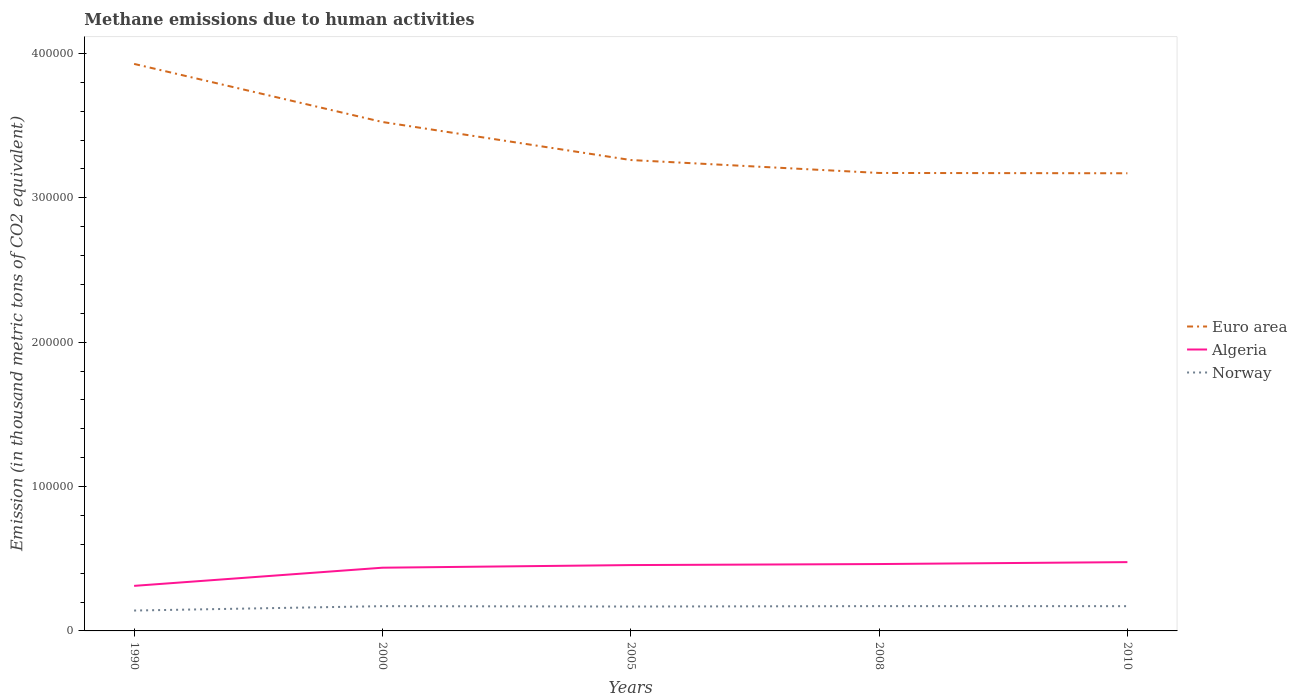Is the number of lines equal to the number of legend labels?
Your answer should be compact. Yes. Across all years, what is the maximum amount of methane emitted in Algeria?
Make the answer very short. 3.12e+04. What is the total amount of methane emitted in Norway in the graph?
Provide a short and direct response. 254.8. What is the difference between the highest and the second highest amount of methane emitted in Euro area?
Offer a very short reply. 7.58e+04. Are the values on the major ticks of Y-axis written in scientific E-notation?
Keep it short and to the point. No. Does the graph contain any zero values?
Offer a terse response. No. Does the graph contain grids?
Ensure brevity in your answer.  No. Where does the legend appear in the graph?
Your answer should be compact. Center right. How are the legend labels stacked?
Offer a very short reply. Vertical. What is the title of the graph?
Provide a short and direct response. Methane emissions due to human activities. Does "Iceland" appear as one of the legend labels in the graph?
Give a very brief answer. No. What is the label or title of the Y-axis?
Make the answer very short. Emission (in thousand metric tons of CO2 equivalent). What is the Emission (in thousand metric tons of CO2 equivalent) in Euro area in 1990?
Provide a succinct answer. 3.93e+05. What is the Emission (in thousand metric tons of CO2 equivalent) of Algeria in 1990?
Your response must be concise. 3.12e+04. What is the Emission (in thousand metric tons of CO2 equivalent) of Norway in 1990?
Make the answer very short. 1.41e+04. What is the Emission (in thousand metric tons of CO2 equivalent) of Euro area in 2000?
Keep it short and to the point. 3.53e+05. What is the Emission (in thousand metric tons of CO2 equivalent) of Algeria in 2000?
Your response must be concise. 4.38e+04. What is the Emission (in thousand metric tons of CO2 equivalent) of Norway in 2000?
Provide a succinct answer. 1.72e+04. What is the Emission (in thousand metric tons of CO2 equivalent) of Euro area in 2005?
Provide a short and direct response. 3.26e+05. What is the Emission (in thousand metric tons of CO2 equivalent) in Algeria in 2005?
Provide a short and direct response. 4.56e+04. What is the Emission (in thousand metric tons of CO2 equivalent) of Norway in 2005?
Offer a very short reply. 1.69e+04. What is the Emission (in thousand metric tons of CO2 equivalent) in Euro area in 2008?
Make the answer very short. 3.17e+05. What is the Emission (in thousand metric tons of CO2 equivalent) in Algeria in 2008?
Your response must be concise. 4.63e+04. What is the Emission (in thousand metric tons of CO2 equivalent) of Norway in 2008?
Your answer should be compact. 1.72e+04. What is the Emission (in thousand metric tons of CO2 equivalent) of Euro area in 2010?
Offer a terse response. 3.17e+05. What is the Emission (in thousand metric tons of CO2 equivalent) in Algeria in 2010?
Offer a terse response. 4.77e+04. What is the Emission (in thousand metric tons of CO2 equivalent) of Norway in 2010?
Your response must be concise. 1.71e+04. Across all years, what is the maximum Emission (in thousand metric tons of CO2 equivalent) of Euro area?
Offer a terse response. 3.93e+05. Across all years, what is the maximum Emission (in thousand metric tons of CO2 equivalent) in Algeria?
Make the answer very short. 4.77e+04. Across all years, what is the maximum Emission (in thousand metric tons of CO2 equivalent) of Norway?
Make the answer very short. 1.72e+04. Across all years, what is the minimum Emission (in thousand metric tons of CO2 equivalent) of Euro area?
Ensure brevity in your answer.  3.17e+05. Across all years, what is the minimum Emission (in thousand metric tons of CO2 equivalent) of Algeria?
Offer a very short reply. 3.12e+04. Across all years, what is the minimum Emission (in thousand metric tons of CO2 equivalent) in Norway?
Make the answer very short. 1.41e+04. What is the total Emission (in thousand metric tons of CO2 equivalent) of Euro area in the graph?
Make the answer very short. 1.71e+06. What is the total Emission (in thousand metric tons of CO2 equivalent) in Algeria in the graph?
Give a very brief answer. 2.15e+05. What is the total Emission (in thousand metric tons of CO2 equivalent) of Norway in the graph?
Your answer should be very brief. 8.25e+04. What is the difference between the Emission (in thousand metric tons of CO2 equivalent) of Euro area in 1990 and that in 2000?
Give a very brief answer. 4.02e+04. What is the difference between the Emission (in thousand metric tons of CO2 equivalent) of Algeria in 1990 and that in 2000?
Your answer should be very brief. -1.26e+04. What is the difference between the Emission (in thousand metric tons of CO2 equivalent) in Norway in 1990 and that in 2000?
Offer a very short reply. -3029.8. What is the difference between the Emission (in thousand metric tons of CO2 equivalent) in Euro area in 1990 and that in 2005?
Offer a very short reply. 6.66e+04. What is the difference between the Emission (in thousand metric tons of CO2 equivalent) in Algeria in 1990 and that in 2005?
Make the answer very short. -1.44e+04. What is the difference between the Emission (in thousand metric tons of CO2 equivalent) of Norway in 1990 and that in 2005?
Provide a short and direct response. -2775. What is the difference between the Emission (in thousand metric tons of CO2 equivalent) of Euro area in 1990 and that in 2008?
Give a very brief answer. 7.55e+04. What is the difference between the Emission (in thousand metric tons of CO2 equivalent) in Algeria in 1990 and that in 2008?
Offer a very short reply. -1.51e+04. What is the difference between the Emission (in thousand metric tons of CO2 equivalent) in Norway in 1990 and that in 2008?
Provide a succinct answer. -3050.8. What is the difference between the Emission (in thousand metric tons of CO2 equivalent) in Euro area in 1990 and that in 2010?
Ensure brevity in your answer.  7.58e+04. What is the difference between the Emission (in thousand metric tons of CO2 equivalent) in Algeria in 1990 and that in 2010?
Keep it short and to the point. -1.64e+04. What is the difference between the Emission (in thousand metric tons of CO2 equivalent) in Norway in 1990 and that in 2010?
Provide a short and direct response. -3026.1. What is the difference between the Emission (in thousand metric tons of CO2 equivalent) in Euro area in 2000 and that in 2005?
Make the answer very short. 2.63e+04. What is the difference between the Emission (in thousand metric tons of CO2 equivalent) in Algeria in 2000 and that in 2005?
Your answer should be very brief. -1815.4. What is the difference between the Emission (in thousand metric tons of CO2 equivalent) in Norway in 2000 and that in 2005?
Provide a short and direct response. 254.8. What is the difference between the Emission (in thousand metric tons of CO2 equivalent) in Euro area in 2000 and that in 2008?
Provide a short and direct response. 3.53e+04. What is the difference between the Emission (in thousand metric tons of CO2 equivalent) in Algeria in 2000 and that in 2008?
Keep it short and to the point. -2532.2. What is the difference between the Emission (in thousand metric tons of CO2 equivalent) in Norway in 2000 and that in 2008?
Offer a very short reply. -21. What is the difference between the Emission (in thousand metric tons of CO2 equivalent) in Euro area in 2000 and that in 2010?
Ensure brevity in your answer.  3.55e+04. What is the difference between the Emission (in thousand metric tons of CO2 equivalent) of Algeria in 2000 and that in 2010?
Give a very brief answer. -3865.2. What is the difference between the Emission (in thousand metric tons of CO2 equivalent) in Norway in 2000 and that in 2010?
Provide a succinct answer. 3.7. What is the difference between the Emission (in thousand metric tons of CO2 equivalent) of Euro area in 2005 and that in 2008?
Provide a succinct answer. 8960.4. What is the difference between the Emission (in thousand metric tons of CO2 equivalent) in Algeria in 2005 and that in 2008?
Your response must be concise. -716.8. What is the difference between the Emission (in thousand metric tons of CO2 equivalent) of Norway in 2005 and that in 2008?
Make the answer very short. -275.8. What is the difference between the Emission (in thousand metric tons of CO2 equivalent) in Euro area in 2005 and that in 2010?
Provide a succinct answer. 9172.4. What is the difference between the Emission (in thousand metric tons of CO2 equivalent) of Algeria in 2005 and that in 2010?
Provide a short and direct response. -2049.8. What is the difference between the Emission (in thousand metric tons of CO2 equivalent) of Norway in 2005 and that in 2010?
Your answer should be compact. -251.1. What is the difference between the Emission (in thousand metric tons of CO2 equivalent) in Euro area in 2008 and that in 2010?
Offer a terse response. 212. What is the difference between the Emission (in thousand metric tons of CO2 equivalent) of Algeria in 2008 and that in 2010?
Offer a very short reply. -1333. What is the difference between the Emission (in thousand metric tons of CO2 equivalent) in Norway in 2008 and that in 2010?
Your response must be concise. 24.7. What is the difference between the Emission (in thousand metric tons of CO2 equivalent) in Euro area in 1990 and the Emission (in thousand metric tons of CO2 equivalent) in Algeria in 2000?
Provide a succinct answer. 3.49e+05. What is the difference between the Emission (in thousand metric tons of CO2 equivalent) of Euro area in 1990 and the Emission (in thousand metric tons of CO2 equivalent) of Norway in 2000?
Keep it short and to the point. 3.76e+05. What is the difference between the Emission (in thousand metric tons of CO2 equivalent) of Algeria in 1990 and the Emission (in thousand metric tons of CO2 equivalent) of Norway in 2000?
Your answer should be compact. 1.41e+04. What is the difference between the Emission (in thousand metric tons of CO2 equivalent) in Euro area in 1990 and the Emission (in thousand metric tons of CO2 equivalent) in Algeria in 2005?
Give a very brief answer. 3.47e+05. What is the difference between the Emission (in thousand metric tons of CO2 equivalent) of Euro area in 1990 and the Emission (in thousand metric tons of CO2 equivalent) of Norway in 2005?
Make the answer very short. 3.76e+05. What is the difference between the Emission (in thousand metric tons of CO2 equivalent) of Algeria in 1990 and the Emission (in thousand metric tons of CO2 equivalent) of Norway in 2005?
Make the answer very short. 1.43e+04. What is the difference between the Emission (in thousand metric tons of CO2 equivalent) in Euro area in 1990 and the Emission (in thousand metric tons of CO2 equivalent) in Algeria in 2008?
Keep it short and to the point. 3.46e+05. What is the difference between the Emission (in thousand metric tons of CO2 equivalent) of Euro area in 1990 and the Emission (in thousand metric tons of CO2 equivalent) of Norway in 2008?
Your answer should be compact. 3.76e+05. What is the difference between the Emission (in thousand metric tons of CO2 equivalent) of Algeria in 1990 and the Emission (in thousand metric tons of CO2 equivalent) of Norway in 2008?
Your response must be concise. 1.40e+04. What is the difference between the Emission (in thousand metric tons of CO2 equivalent) of Euro area in 1990 and the Emission (in thousand metric tons of CO2 equivalent) of Algeria in 2010?
Provide a short and direct response. 3.45e+05. What is the difference between the Emission (in thousand metric tons of CO2 equivalent) in Euro area in 1990 and the Emission (in thousand metric tons of CO2 equivalent) in Norway in 2010?
Provide a succinct answer. 3.76e+05. What is the difference between the Emission (in thousand metric tons of CO2 equivalent) of Algeria in 1990 and the Emission (in thousand metric tons of CO2 equivalent) of Norway in 2010?
Provide a succinct answer. 1.41e+04. What is the difference between the Emission (in thousand metric tons of CO2 equivalent) of Euro area in 2000 and the Emission (in thousand metric tons of CO2 equivalent) of Algeria in 2005?
Your answer should be very brief. 3.07e+05. What is the difference between the Emission (in thousand metric tons of CO2 equivalent) in Euro area in 2000 and the Emission (in thousand metric tons of CO2 equivalent) in Norway in 2005?
Give a very brief answer. 3.36e+05. What is the difference between the Emission (in thousand metric tons of CO2 equivalent) in Algeria in 2000 and the Emission (in thousand metric tons of CO2 equivalent) in Norway in 2005?
Offer a very short reply. 2.69e+04. What is the difference between the Emission (in thousand metric tons of CO2 equivalent) of Euro area in 2000 and the Emission (in thousand metric tons of CO2 equivalent) of Algeria in 2008?
Ensure brevity in your answer.  3.06e+05. What is the difference between the Emission (in thousand metric tons of CO2 equivalent) in Euro area in 2000 and the Emission (in thousand metric tons of CO2 equivalent) in Norway in 2008?
Provide a succinct answer. 3.35e+05. What is the difference between the Emission (in thousand metric tons of CO2 equivalent) in Algeria in 2000 and the Emission (in thousand metric tons of CO2 equivalent) in Norway in 2008?
Make the answer very short. 2.66e+04. What is the difference between the Emission (in thousand metric tons of CO2 equivalent) in Euro area in 2000 and the Emission (in thousand metric tons of CO2 equivalent) in Algeria in 2010?
Offer a terse response. 3.05e+05. What is the difference between the Emission (in thousand metric tons of CO2 equivalent) of Euro area in 2000 and the Emission (in thousand metric tons of CO2 equivalent) of Norway in 2010?
Your answer should be very brief. 3.35e+05. What is the difference between the Emission (in thousand metric tons of CO2 equivalent) in Algeria in 2000 and the Emission (in thousand metric tons of CO2 equivalent) in Norway in 2010?
Make the answer very short. 2.66e+04. What is the difference between the Emission (in thousand metric tons of CO2 equivalent) of Euro area in 2005 and the Emission (in thousand metric tons of CO2 equivalent) of Algeria in 2008?
Give a very brief answer. 2.80e+05. What is the difference between the Emission (in thousand metric tons of CO2 equivalent) in Euro area in 2005 and the Emission (in thousand metric tons of CO2 equivalent) in Norway in 2008?
Your response must be concise. 3.09e+05. What is the difference between the Emission (in thousand metric tons of CO2 equivalent) of Algeria in 2005 and the Emission (in thousand metric tons of CO2 equivalent) of Norway in 2008?
Provide a short and direct response. 2.84e+04. What is the difference between the Emission (in thousand metric tons of CO2 equivalent) of Euro area in 2005 and the Emission (in thousand metric tons of CO2 equivalent) of Algeria in 2010?
Your answer should be compact. 2.79e+05. What is the difference between the Emission (in thousand metric tons of CO2 equivalent) of Euro area in 2005 and the Emission (in thousand metric tons of CO2 equivalent) of Norway in 2010?
Provide a succinct answer. 3.09e+05. What is the difference between the Emission (in thousand metric tons of CO2 equivalent) of Algeria in 2005 and the Emission (in thousand metric tons of CO2 equivalent) of Norway in 2010?
Offer a terse response. 2.85e+04. What is the difference between the Emission (in thousand metric tons of CO2 equivalent) of Euro area in 2008 and the Emission (in thousand metric tons of CO2 equivalent) of Algeria in 2010?
Offer a very short reply. 2.70e+05. What is the difference between the Emission (in thousand metric tons of CO2 equivalent) of Euro area in 2008 and the Emission (in thousand metric tons of CO2 equivalent) of Norway in 2010?
Your answer should be very brief. 3.00e+05. What is the difference between the Emission (in thousand metric tons of CO2 equivalent) in Algeria in 2008 and the Emission (in thousand metric tons of CO2 equivalent) in Norway in 2010?
Your response must be concise. 2.92e+04. What is the average Emission (in thousand metric tons of CO2 equivalent) in Euro area per year?
Your answer should be compact. 3.41e+05. What is the average Emission (in thousand metric tons of CO2 equivalent) of Algeria per year?
Provide a succinct answer. 4.29e+04. What is the average Emission (in thousand metric tons of CO2 equivalent) of Norway per year?
Your answer should be very brief. 1.65e+04. In the year 1990, what is the difference between the Emission (in thousand metric tons of CO2 equivalent) of Euro area and Emission (in thousand metric tons of CO2 equivalent) of Algeria?
Keep it short and to the point. 3.62e+05. In the year 1990, what is the difference between the Emission (in thousand metric tons of CO2 equivalent) of Euro area and Emission (in thousand metric tons of CO2 equivalent) of Norway?
Your answer should be compact. 3.79e+05. In the year 1990, what is the difference between the Emission (in thousand metric tons of CO2 equivalent) in Algeria and Emission (in thousand metric tons of CO2 equivalent) in Norway?
Ensure brevity in your answer.  1.71e+04. In the year 2000, what is the difference between the Emission (in thousand metric tons of CO2 equivalent) of Euro area and Emission (in thousand metric tons of CO2 equivalent) of Algeria?
Give a very brief answer. 3.09e+05. In the year 2000, what is the difference between the Emission (in thousand metric tons of CO2 equivalent) of Euro area and Emission (in thousand metric tons of CO2 equivalent) of Norway?
Provide a short and direct response. 3.35e+05. In the year 2000, what is the difference between the Emission (in thousand metric tons of CO2 equivalent) of Algeria and Emission (in thousand metric tons of CO2 equivalent) of Norway?
Your response must be concise. 2.66e+04. In the year 2005, what is the difference between the Emission (in thousand metric tons of CO2 equivalent) of Euro area and Emission (in thousand metric tons of CO2 equivalent) of Algeria?
Provide a short and direct response. 2.81e+05. In the year 2005, what is the difference between the Emission (in thousand metric tons of CO2 equivalent) of Euro area and Emission (in thousand metric tons of CO2 equivalent) of Norway?
Your answer should be compact. 3.09e+05. In the year 2005, what is the difference between the Emission (in thousand metric tons of CO2 equivalent) of Algeria and Emission (in thousand metric tons of CO2 equivalent) of Norway?
Provide a short and direct response. 2.87e+04. In the year 2008, what is the difference between the Emission (in thousand metric tons of CO2 equivalent) of Euro area and Emission (in thousand metric tons of CO2 equivalent) of Algeria?
Your response must be concise. 2.71e+05. In the year 2008, what is the difference between the Emission (in thousand metric tons of CO2 equivalent) of Euro area and Emission (in thousand metric tons of CO2 equivalent) of Norway?
Your answer should be compact. 3.00e+05. In the year 2008, what is the difference between the Emission (in thousand metric tons of CO2 equivalent) in Algeria and Emission (in thousand metric tons of CO2 equivalent) in Norway?
Your answer should be very brief. 2.92e+04. In the year 2010, what is the difference between the Emission (in thousand metric tons of CO2 equivalent) of Euro area and Emission (in thousand metric tons of CO2 equivalent) of Algeria?
Offer a very short reply. 2.69e+05. In the year 2010, what is the difference between the Emission (in thousand metric tons of CO2 equivalent) in Euro area and Emission (in thousand metric tons of CO2 equivalent) in Norway?
Give a very brief answer. 3.00e+05. In the year 2010, what is the difference between the Emission (in thousand metric tons of CO2 equivalent) in Algeria and Emission (in thousand metric tons of CO2 equivalent) in Norway?
Offer a terse response. 3.05e+04. What is the ratio of the Emission (in thousand metric tons of CO2 equivalent) of Euro area in 1990 to that in 2000?
Give a very brief answer. 1.11. What is the ratio of the Emission (in thousand metric tons of CO2 equivalent) of Algeria in 1990 to that in 2000?
Offer a very short reply. 0.71. What is the ratio of the Emission (in thousand metric tons of CO2 equivalent) in Norway in 1990 to that in 2000?
Keep it short and to the point. 0.82. What is the ratio of the Emission (in thousand metric tons of CO2 equivalent) in Euro area in 1990 to that in 2005?
Ensure brevity in your answer.  1.2. What is the ratio of the Emission (in thousand metric tons of CO2 equivalent) in Algeria in 1990 to that in 2005?
Offer a terse response. 0.68. What is the ratio of the Emission (in thousand metric tons of CO2 equivalent) of Norway in 1990 to that in 2005?
Offer a very short reply. 0.84. What is the ratio of the Emission (in thousand metric tons of CO2 equivalent) of Euro area in 1990 to that in 2008?
Offer a very short reply. 1.24. What is the ratio of the Emission (in thousand metric tons of CO2 equivalent) of Algeria in 1990 to that in 2008?
Offer a very short reply. 0.67. What is the ratio of the Emission (in thousand metric tons of CO2 equivalent) of Norway in 1990 to that in 2008?
Ensure brevity in your answer.  0.82. What is the ratio of the Emission (in thousand metric tons of CO2 equivalent) in Euro area in 1990 to that in 2010?
Keep it short and to the point. 1.24. What is the ratio of the Emission (in thousand metric tons of CO2 equivalent) of Algeria in 1990 to that in 2010?
Ensure brevity in your answer.  0.65. What is the ratio of the Emission (in thousand metric tons of CO2 equivalent) of Norway in 1990 to that in 2010?
Make the answer very short. 0.82. What is the ratio of the Emission (in thousand metric tons of CO2 equivalent) of Euro area in 2000 to that in 2005?
Make the answer very short. 1.08. What is the ratio of the Emission (in thousand metric tons of CO2 equivalent) in Algeria in 2000 to that in 2005?
Your response must be concise. 0.96. What is the ratio of the Emission (in thousand metric tons of CO2 equivalent) of Norway in 2000 to that in 2005?
Your answer should be very brief. 1.02. What is the ratio of the Emission (in thousand metric tons of CO2 equivalent) of Euro area in 2000 to that in 2008?
Provide a short and direct response. 1.11. What is the ratio of the Emission (in thousand metric tons of CO2 equivalent) in Algeria in 2000 to that in 2008?
Your answer should be compact. 0.95. What is the ratio of the Emission (in thousand metric tons of CO2 equivalent) of Euro area in 2000 to that in 2010?
Give a very brief answer. 1.11. What is the ratio of the Emission (in thousand metric tons of CO2 equivalent) of Algeria in 2000 to that in 2010?
Keep it short and to the point. 0.92. What is the ratio of the Emission (in thousand metric tons of CO2 equivalent) in Norway in 2000 to that in 2010?
Your response must be concise. 1. What is the ratio of the Emission (in thousand metric tons of CO2 equivalent) of Euro area in 2005 to that in 2008?
Offer a very short reply. 1.03. What is the ratio of the Emission (in thousand metric tons of CO2 equivalent) in Algeria in 2005 to that in 2008?
Offer a terse response. 0.98. What is the ratio of the Emission (in thousand metric tons of CO2 equivalent) in Norway in 2005 to that in 2008?
Offer a terse response. 0.98. What is the ratio of the Emission (in thousand metric tons of CO2 equivalent) of Euro area in 2005 to that in 2010?
Your answer should be compact. 1.03. What is the ratio of the Emission (in thousand metric tons of CO2 equivalent) of Norway in 2005 to that in 2010?
Your answer should be very brief. 0.99. What is the ratio of the Emission (in thousand metric tons of CO2 equivalent) of Euro area in 2008 to that in 2010?
Keep it short and to the point. 1. What is the ratio of the Emission (in thousand metric tons of CO2 equivalent) in Norway in 2008 to that in 2010?
Give a very brief answer. 1. What is the difference between the highest and the second highest Emission (in thousand metric tons of CO2 equivalent) in Euro area?
Ensure brevity in your answer.  4.02e+04. What is the difference between the highest and the second highest Emission (in thousand metric tons of CO2 equivalent) in Algeria?
Offer a very short reply. 1333. What is the difference between the highest and the lowest Emission (in thousand metric tons of CO2 equivalent) in Euro area?
Make the answer very short. 7.58e+04. What is the difference between the highest and the lowest Emission (in thousand metric tons of CO2 equivalent) of Algeria?
Provide a succinct answer. 1.64e+04. What is the difference between the highest and the lowest Emission (in thousand metric tons of CO2 equivalent) of Norway?
Provide a short and direct response. 3050.8. 